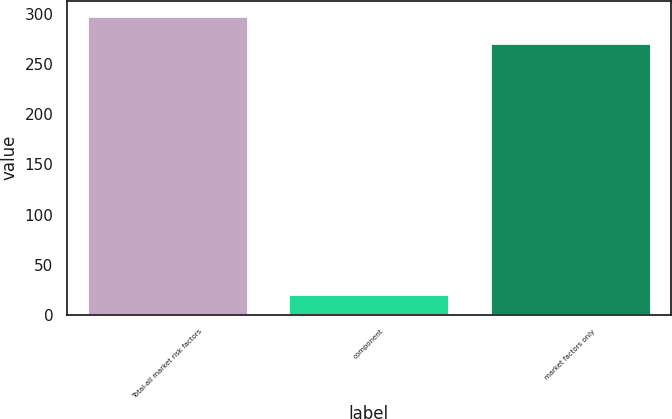Convert chart to OTSL. <chart><loc_0><loc_0><loc_500><loc_500><bar_chart><fcel>Total-all market risk factors<fcel>component<fcel>market factors only<nl><fcel>298.1<fcel>21<fcel>271<nl></chart> 